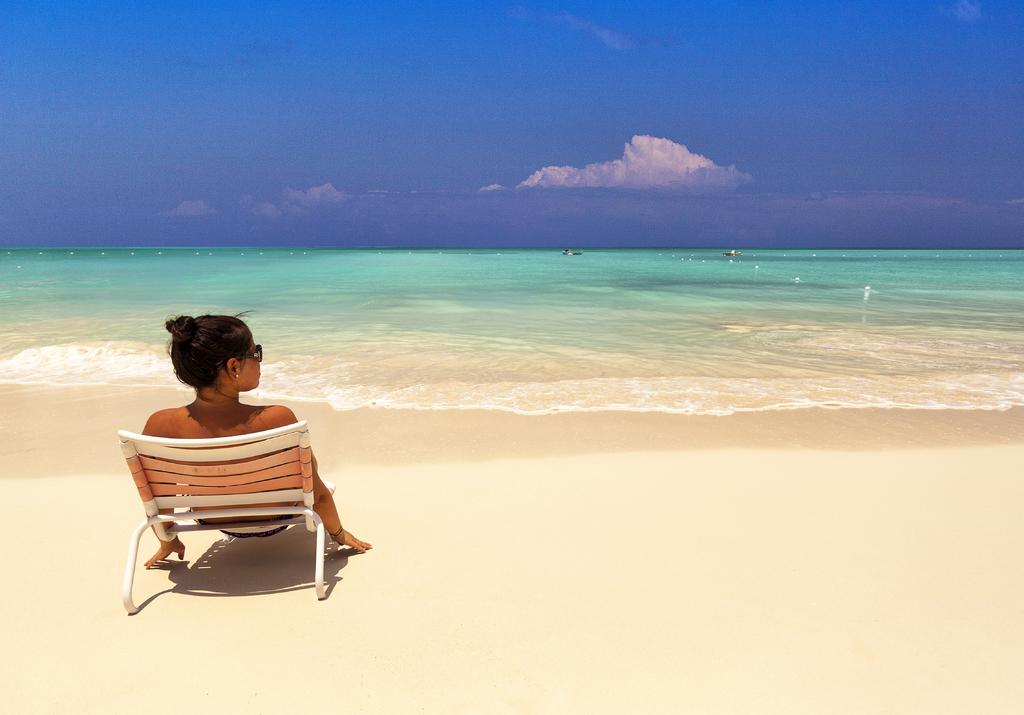Who is present in the image? There is a person in the image. What is the person wearing? The person is wearing goggles. What is the person's position in the image? The person is sitting on a chair. What can be seen on the water in the image? There are objects on the water in the image. What is the condition of the sky in the background? The sky in the background is cloudy. What type of hearing aid is the person using in the image? The person is not using a hearing aid in the image; they are wearing goggles. What is inside the sack that the person is holding in the image? There is no sack present in the image. 